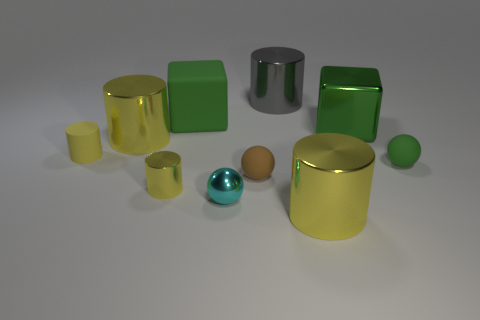Subtract all yellow balls. How many yellow cylinders are left? 4 Subtract all gray cylinders. How many cylinders are left? 4 Subtract all gray metal cylinders. How many cylinders are left? 4 Subtract all green cylinders. Subtract all yellow blocks. How many cylinders are left? 5 Subtract all cubes. How many objects are left? 8 Add 8 gray objects. How many gray objects are left? 9 Add 3 big objects. How many big objects exist? 8 Subtract 0 green cylinders. How many objects are left? 10 Subtract all brown matte spheres. Subtract all big cylinders. How many objects are left? 6 